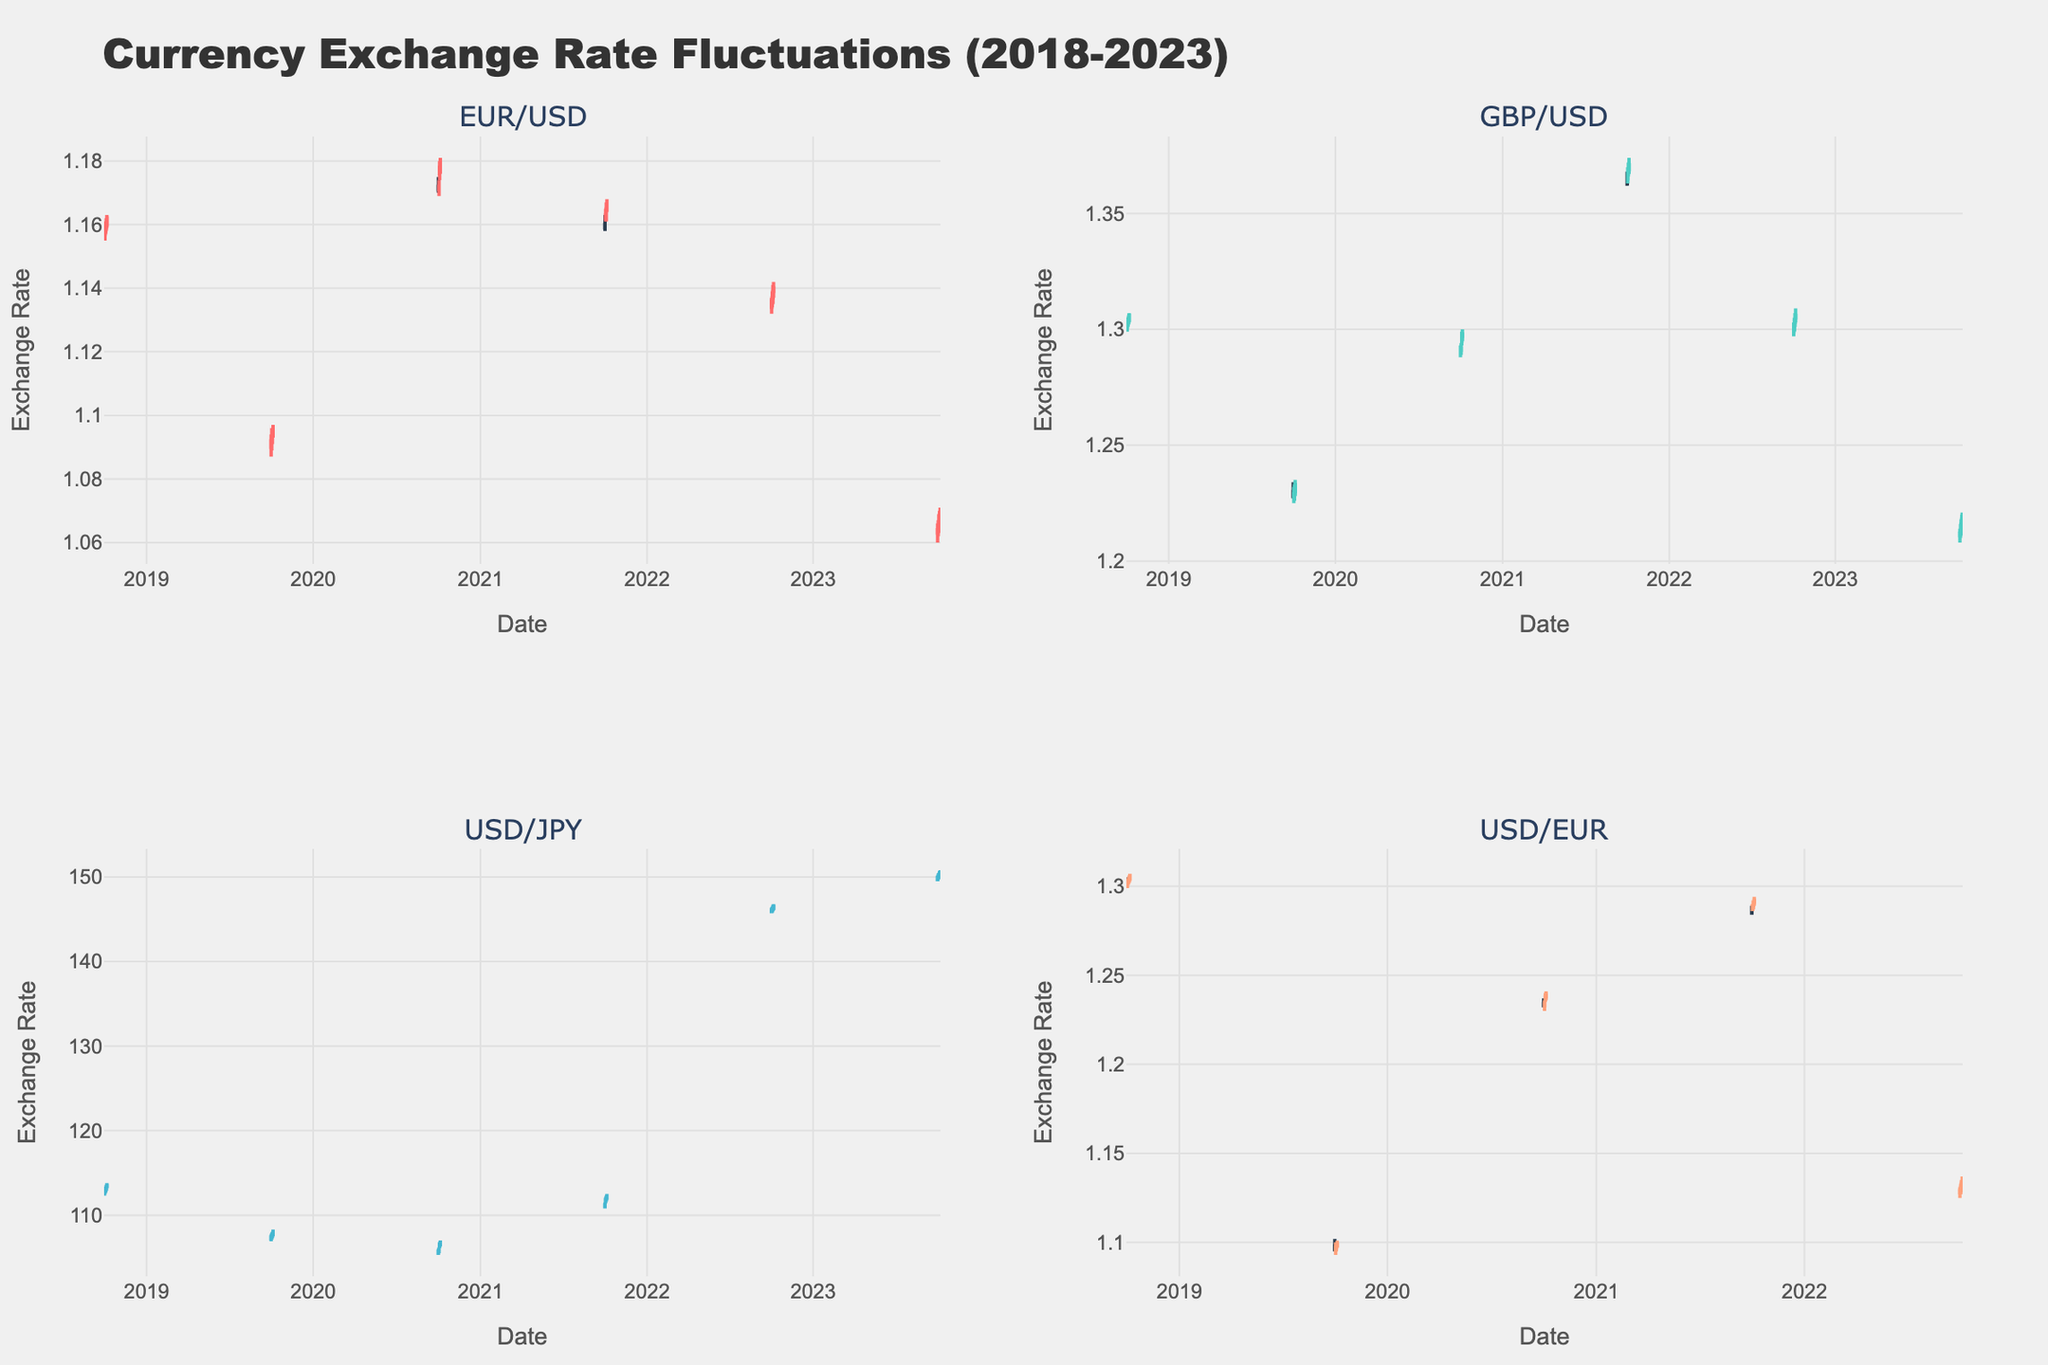What is the title of the candlestick plot? The title of the plot is usually found at the top of the figure. In this case, it's clearly labeled "Currency Exchange Rate Fluctuations (2018-2023)."
Answer: Currency Exchange Rate Fluctuations (2018-2023) What are the x-axis and y-axis labels? The x-axis and y-axis labels can be identified by the text labeling along the bottom and side edges of the plot. Here, the x-axis is labeled "Date" and the y-axis is labeled "Exchange Rate."
Answer: Date, Exchange Rate How many subplots are in the figure and which currency pairs do they represent? The layout of the figure is divided into four subplots, each titled with a currency pair name. These are "EUR/USD," "GBP/USD," "USD/JPY," and "USD/EUR."
Answer: 4 subplots, representing EUR/USD, GBP/USD, USD/JPY, and USD/EUR Which currency pair shows the highest exchange rate in any of the subplots, and what is that rate? The highest exchange rate can be seen by checking the peaks of the candlesticks across all subplots. The subplot for USD/JPY shows the highest rate at around 146.80.
Answer: USD/JPY, 146.80 Which currency pair has the least volatility over the entire time period? Volatility is indicated by the length of the candlesticks. The EUR/USD subplot appears to have shorter candlesticks compared to others, indicating less volatility.
Answer: EUR/USD During the date range shown, which currency pair had the largest single-day range (high minus low) and what was the range? To find the single-day range, look for the tallest individual candlestick in any subplot. For example, USD/JPY on 2022-10-06 had a high of 146.80 and a low of 146.10, a range of 0.70.
Answer: USD/JPY, 0.70 Which subplot has the highest trading volume and what is that volume? Trading volume is often shown as bars at the bottom of the candlestick plot. Among the subplots, USD/JPY on 2023-10-01 had the highest volume of 1650.
Answer: USD/JPY, 1650 How did the closing rate for GBP/USD change from the end of 2018 to the end of 2023? Identify the closing rates for GBP/USD at the end of the years 2018 and 2023. In 2018 it was 1.307 and in 2023 it was 1.219. The change is 1.219 - 1.307 = -0.088.
Answer: Decreased by 0.088 Which currency pair shows increased trading volumes from year 2018 to 2023, and by how much? Compare the trading volumes at similar dates across years. For example, GBP/USD on 2018-10-06 had 1705 and on 2023-10-06 had 1545. The volume decreased by 160.
Answer: No pair shows increased volume Is the closing rate for EUR/USD on 2020-10-06 higher or lower than the closing rate on 2018-10-06? Check the closing rates for the specified dates. For EUR/USD, the closing rate on 2020-10-06 was 1.179 and on 2018-10-06 was 1.164. 1.179 is higher.
Answer: Higher 